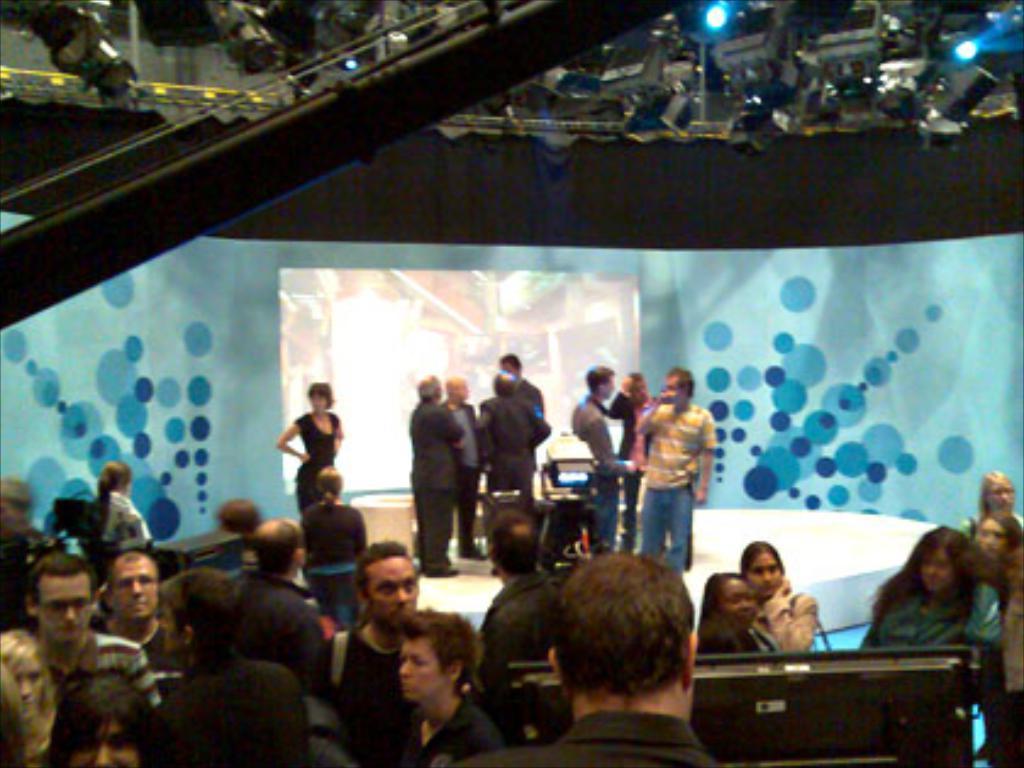Please provide a concise description of this image. In this image there are few people present on the stage and few are present on the floor. At the top there are cameras and also lights. Screen is also visible in this image. 